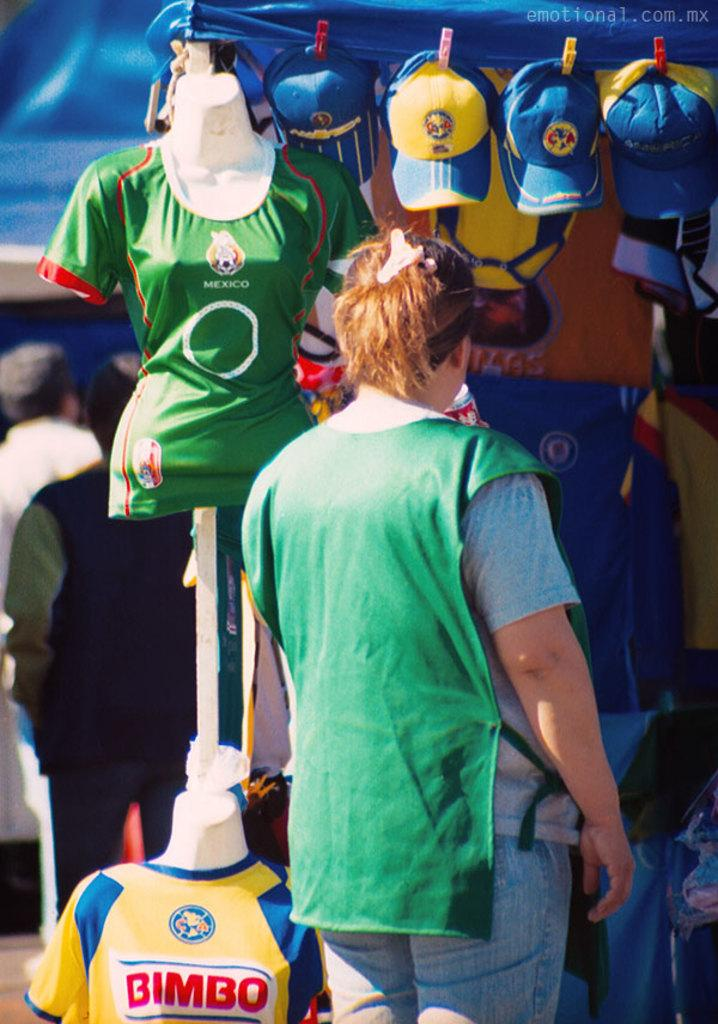How many people are in the image? There are three people standing in the image. What are some of the people wearing? Some of the people are wearing T-shirts and caps. Can you describe any objects present in the image? Unfortunately, the provided facts do not specify any objects present in the image. How many tomatoes can be seen growing in the alley in the image? There is no alley or tomatoes present in the image. 